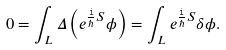Convert formula to latex. <formula><loc_0><loc_0><loc_500><loc_500>0 = \int _ { L } \Delta \left ( e ^ { \frac { \tt i } \hbar { S } } \phi \right ) = \int _ { L } e ^ { \frac { \tt i } \hbar { S } } \delta \phi .</formula> 